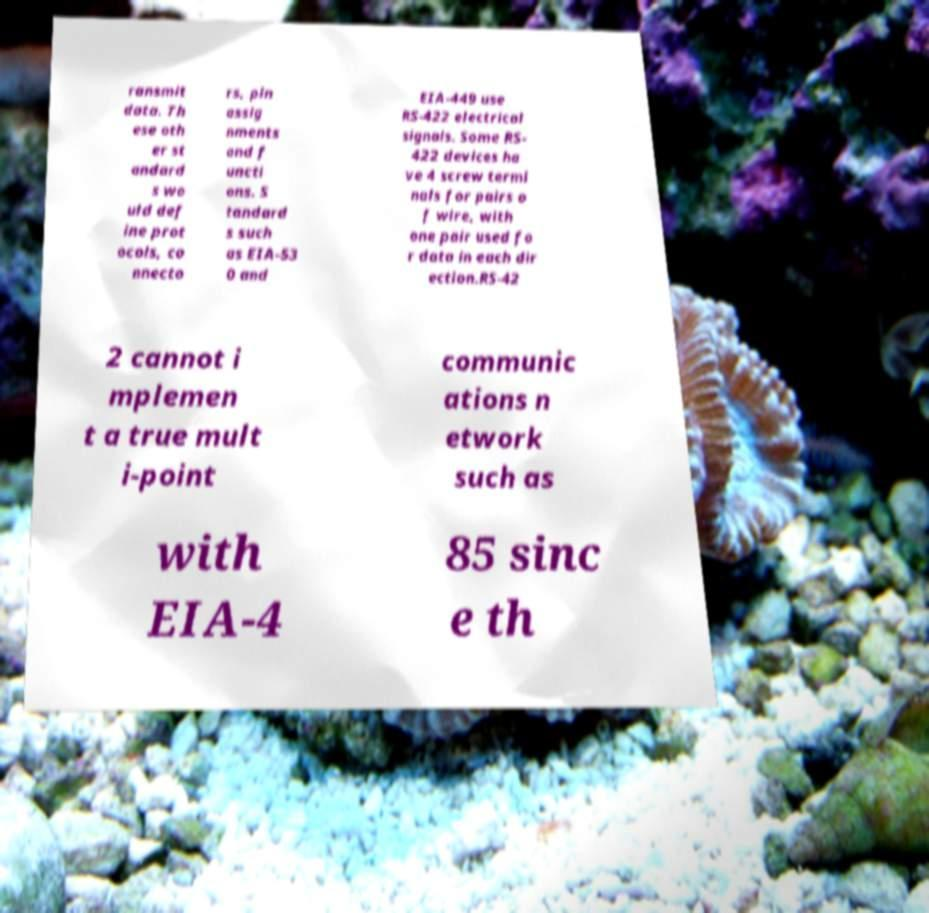What messages or text are displayed in this image? I need them in a readable, typed format. ransmit data. Th ese oth er st andard s wo uld def ine prot ocols, co nnecto rs, pin assig nments and f uncti ons. S tandard s such as EIA-53 0 and EIA-449 use RS-422 electrical signals. Some RS- 422 devices ha ve 4 screw termi nals for pairs o f wire, with one pair used fo r data in each dir ection.RS-42 2 cannot i mplemen t a true mult i-point communic ations n etwork such as with EIA-4 85 sinc e th 